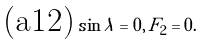Convert formula to latex. <formula><loc_0><loc_0><loc_500><loc_500>\text {(a12)} \, \sin \lambda = 0 , \, F _ { 2 } = 0 .</formula> 